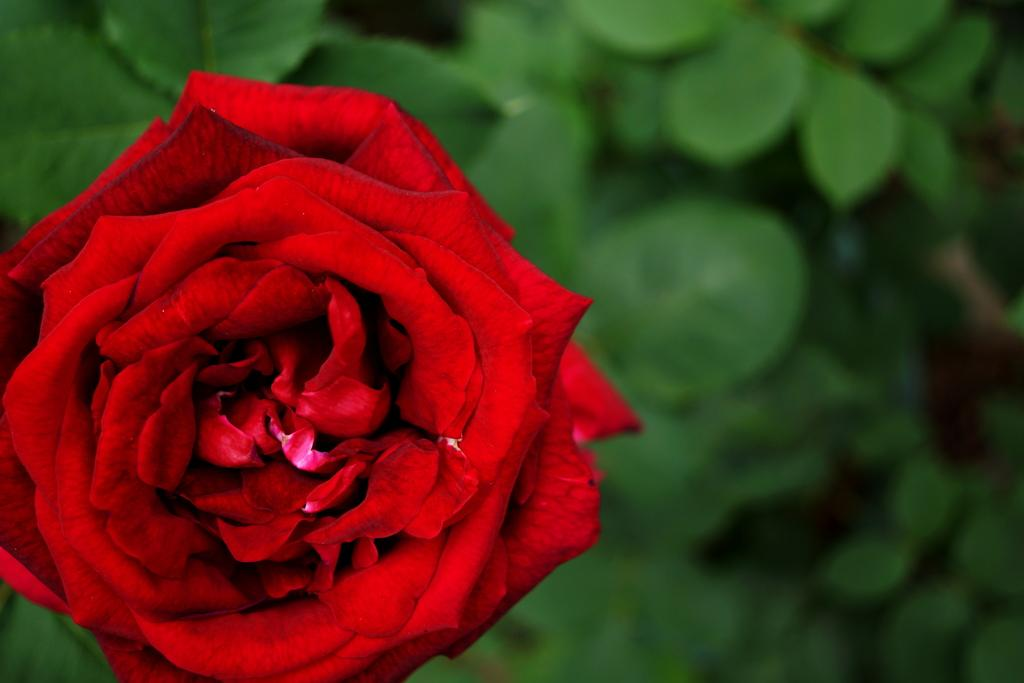What type of flower is in the image? There is a red rose in the image. Where is the red rose located in the image? The rose is in the front of the image. What type of vegetation is visible in the background of the image? There are green leaves in the background of the image. How would you describe the quality of the image in the background? The image is slightly blurry in the background. What type of suit is hanging on the wall in the image? There is no suit present in the image; it features a red rose in the front and green leaves in the background. 